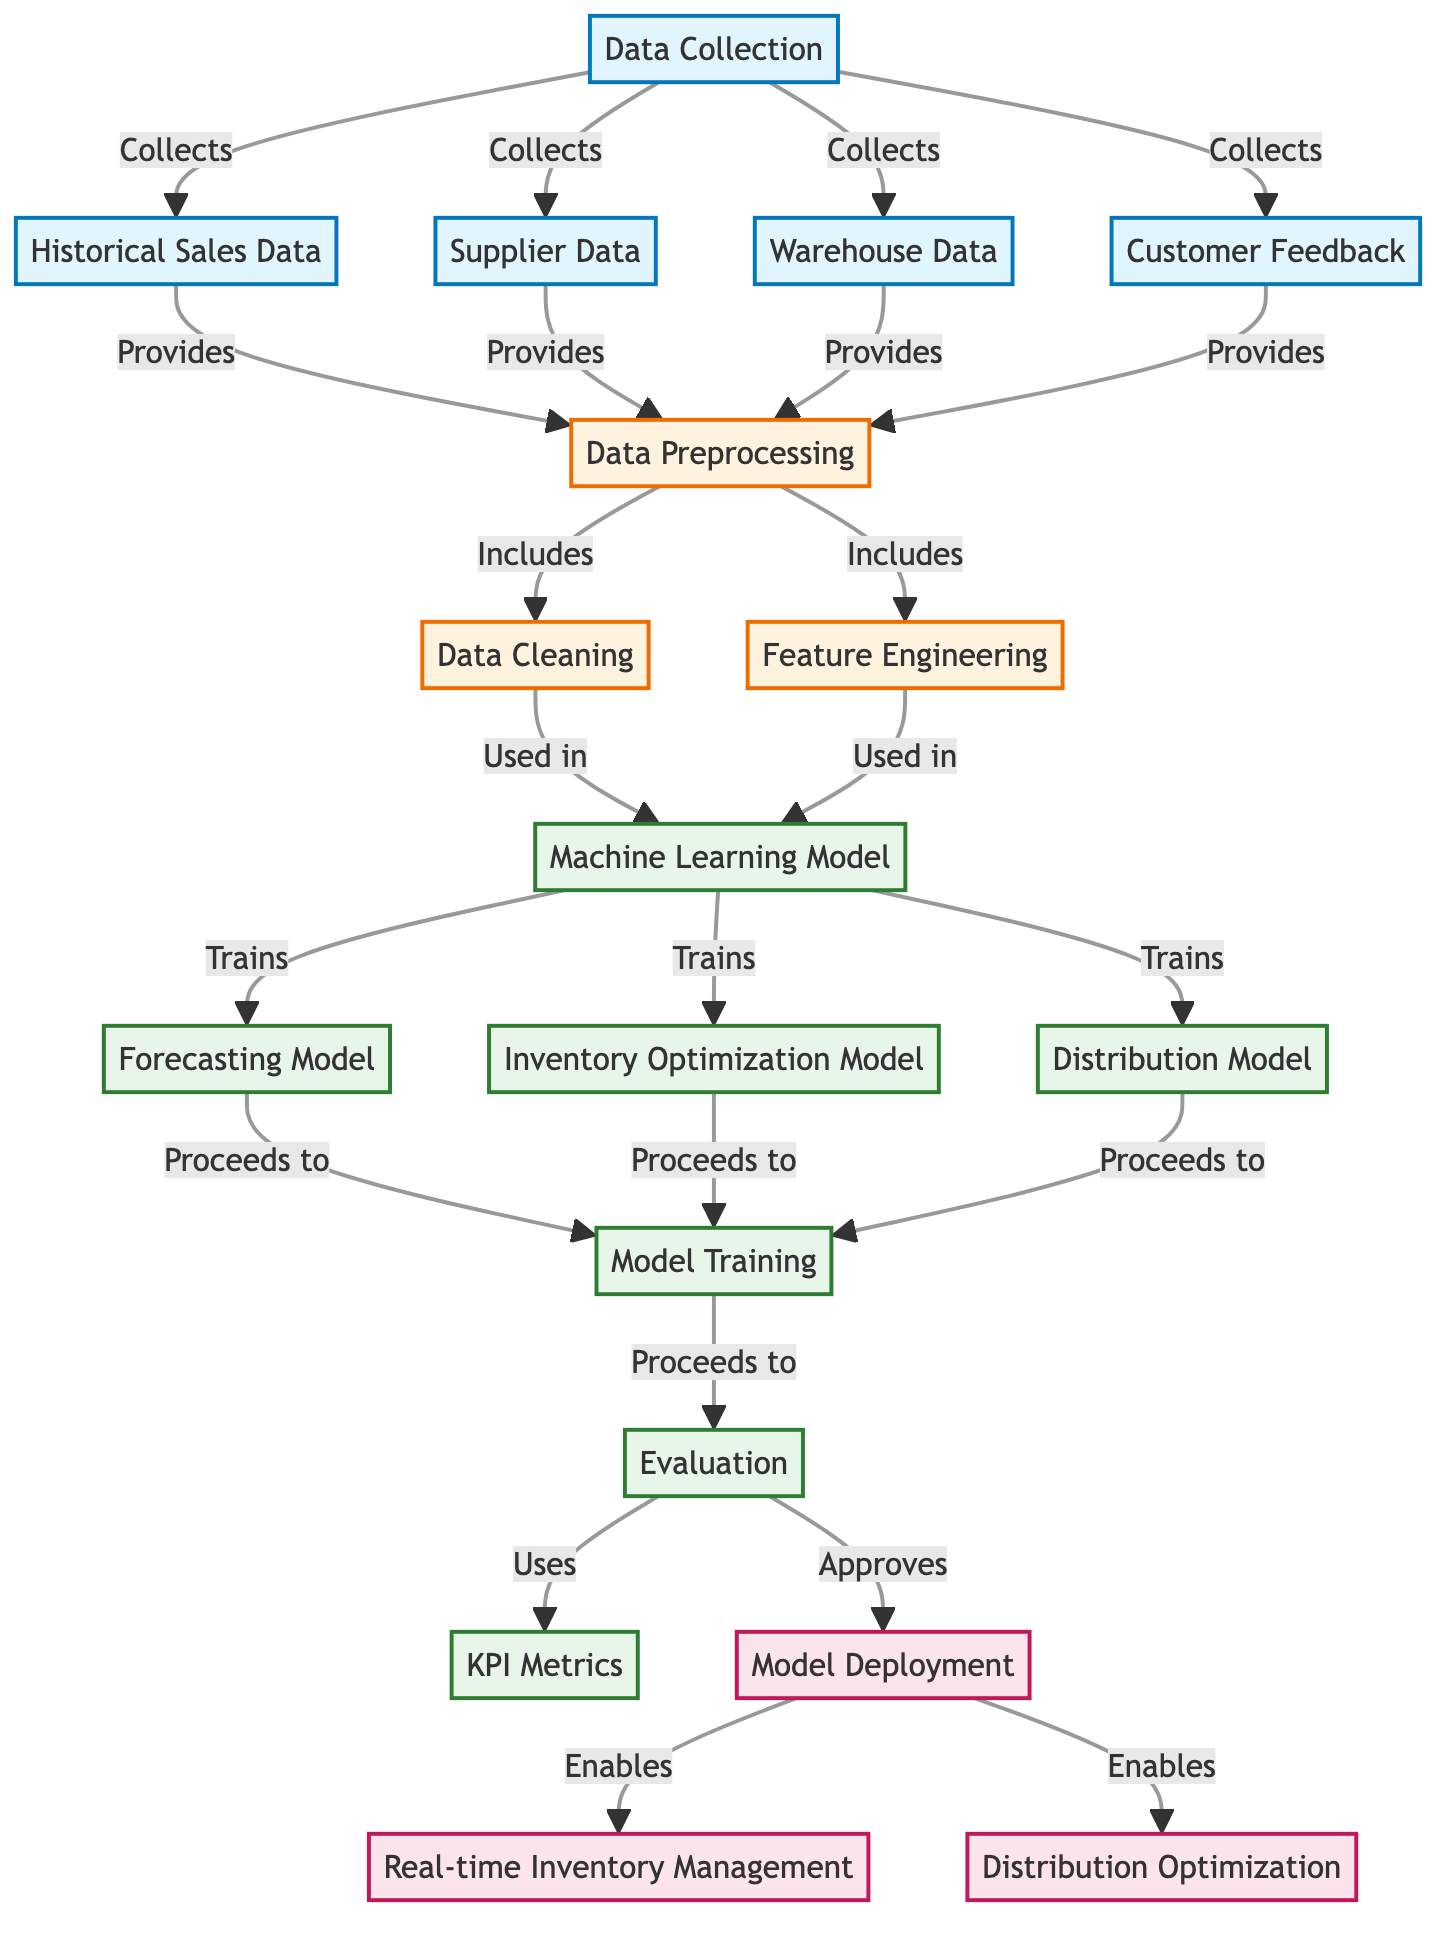What are the four main data sources for collection? The diagram indicates that the main data sources for collection are historical sales data, supplier data, warehouse data, and customer feedback. These sources are directly linked as inputs to the data collection node.
Answer: historical sales data, supplier data, warehouse data, customer feedback How many models are being trained in the machine learning process? According to the diagram, three models are trained: the forecasting model, the inventory optimization model, and the distribution model. These models are outcomes of the machine learning model and are grouped together in one node.
Answer: three models What follows after model training in the workflow? The workflow proceeds from model training to evaluation. This is shown as a direct connection in the diagram, indicating that evaluation comes next after the training process.
Answer: evaluation What are two outputs enabled by model deployment? The model deployment enables real-time inventory management and distribution optimization as outputs, demonstrating what functionality is made possible once the model is deployed.
Answer: real-time inventory management, distribution optimization What stage comes directly after data preprocessing? Immediately after data preprocessing in the diagram is the machine learning model. This indicates that the preprocessing step feeds directly into the model creation step.
Answer: machine learning model Which step includes data cleaning and feature engineering? The data preprocessing step specifically includes data cleaning and feature engineering, as indicated by the direct link connecting these stages in the workflow of the diagram.
Answer: data preprocessing What is used to evaluate the models' performance? KPI metrics are used to evaluate the model's performance, as indicated by the flow from evaluation to KPI metrics in the diagram. This suggests that the evaluation step relies on these metrics.
Answer: KPI metrics 